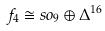Convert formula to latex. <formula><loc_0><loc_0><loc_500><loc_500>f _ { 4 } \cong s o _ { 9 } \oplus \Delta ^ { 1 6 }</formula> 